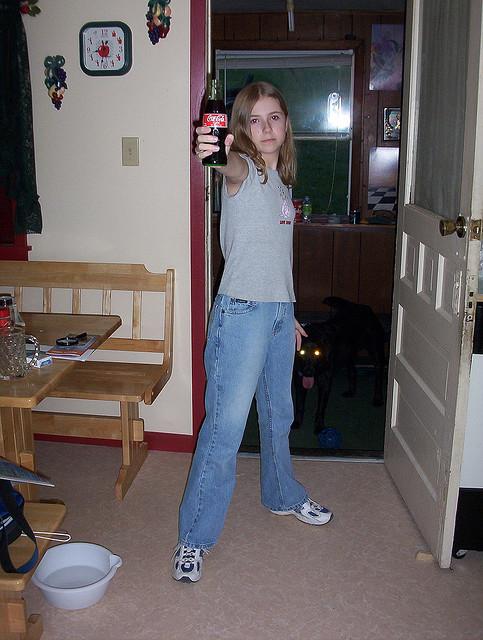What color is the woman's shirt?
Quick response, please. Gray. What is making the dog's eyes glow?
Short answer required. Camera flash. What kind of pants is she wearing?
Write a very short answer. Jeans. What type of drink is she holding?
Write a very short answer. Coke. What does the girls shirt say?
Write a very short answer. Life 2000. What is the person holding?
Short answer required. Coke. What game system are the kids playing?
Write a very short answer. None. What is this person doing?
Quick response, please. Holding soda. What is the color of her shirt?
Be succinct. Gray. What color is the carpet?
Write a very short answer. Beige. What type of shoes is the person wearing?
Give a very brief answer. Sneakers. What is the girl doing?
Answer briefly. Posing. 